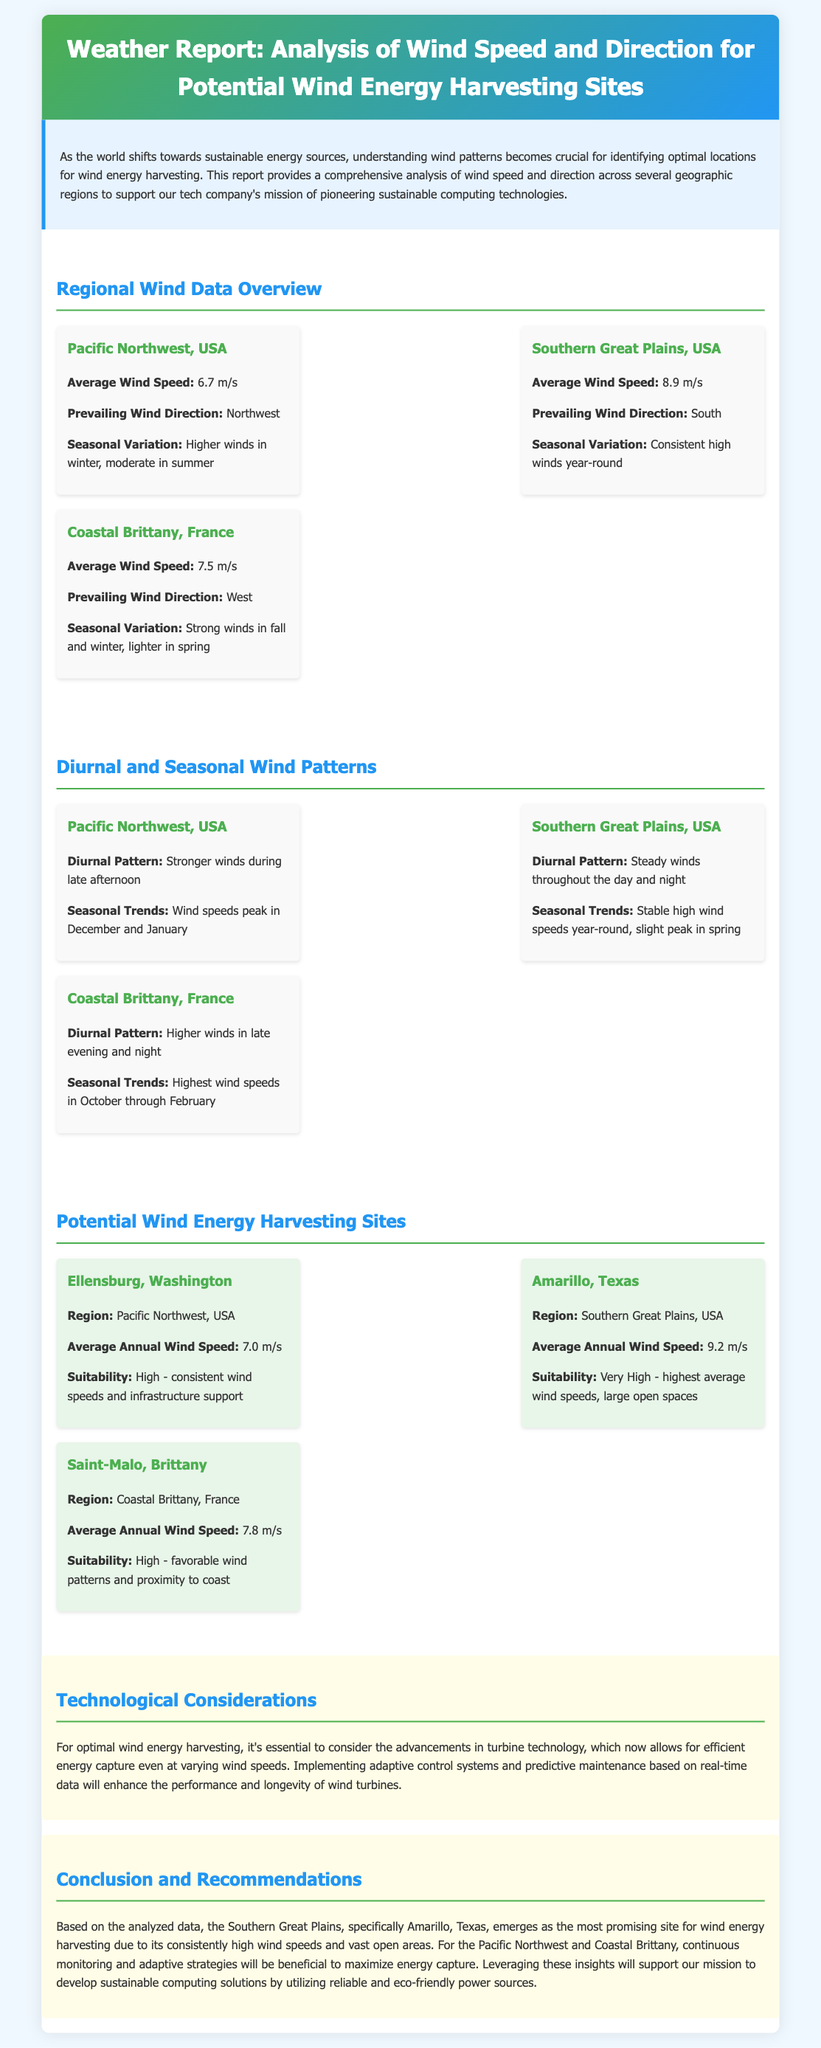What is the average wind speed in the Southern Great Plains? The document states that the average wind speed in the Southern Great Plains is 8.9 m/s.
Answer: 8.9 m/s What season has higher winds in the Pacific Northwest? Higher winds in the Pacific Northwest occur in winter.
Answer: Winter What is the prevailing wind direction in Coastal Brittany, France? The prevailing wind direction mentioned for Coastal Brittany, France, is West.
Answer: West Which site has the highest average annual wind speed? The document indicates that Amarillo, Texas, has the highest average annual wind speed at 9.2 m/s.
Answer: 9.2 m/s What are the seasonal trends for wind speeds in Coastal Brittany? According to the document, wind speeds are highest in October through February in Coastal Brittany.
Answer: October through February What recommendation is made for the Pacific Northwest? The document recommends continuous monitoring and adaptive strategies for the Pacific Northwest.
Answer: Continuous monitoring and adaptive strategies What is the suitability rating for Saint-Malo, Brittany? The suitability rating for Saint-Malo, Brittany, is High.
Answer: High What time of day do stronger winds occur in the Pacific Northwest? Stronger winds in the Pacific Northwest occur during the late afternoon.
Answer: Late afternoon What is the primary focus of the document? The primary focus of the document is analysis of wind speed and direction for potential wind energy harvesting sites.
Answer: Analysis of wind speed and direction for potential wind energy harvesting sites 